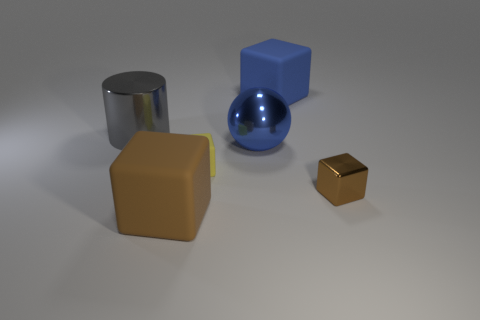Add 4 tiny purple matte cylinders. How many objects exist? 10 Subtract all blocks. How many objects are left? 2 Add 4 large spheres. How many large spheres exist? 5 Subtract 0 yellow cylinders. How many objects are left? 6 Subtract all tiny brown things. Subtract all large cyan metal objects. How many objects are left? 5 Add 1 big blue rubber things. How many big blue rubber things are left? 2 